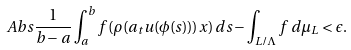Convert formula to latex. <formula><loc_0><loc_0><loc_500><loc_500>\ A b s { \frac { 1 } { b - a } \int _ { a } ^ { b } f ( \rho ( a _ { t } u ( \phi ( s ) ) ) x ) \, d s - \int _ { L / \Lambda } f \, d \mu _ { L } } < \epsilon .</formula> 